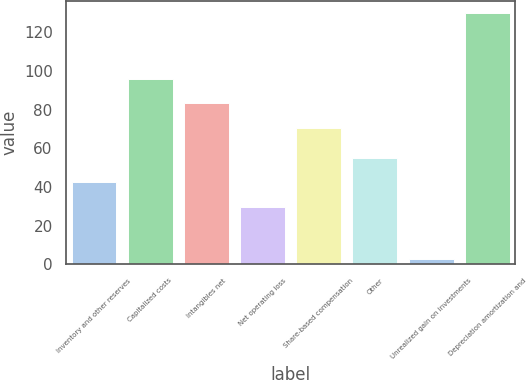Convert chart to OTSL. <chart><loc_0><loc_0><loc_500><loc_500><bar_chart><fcel>Inventory and other reserves<fcel>Capitalized costs<fcel>Intangibles net<fcel>Net operating loss<fcel>Share-based compensation<fcel>Other<fcel>Unrealized gain on investments<fcel>Depreciation amortization and<nl><fcel>42.31<fcel>95.92<fcel>83.21<fcel>29.6<fcel>70.5<fcel>55.02<fcel>2.7<fcel>129.8<nl></chart> 